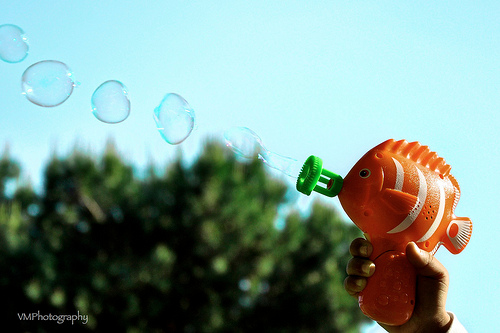<image>
Can you confirm if the bubble is above the fish? Yes. The bubble is positioned above the fish in the vertical space, higher up in the scene. 